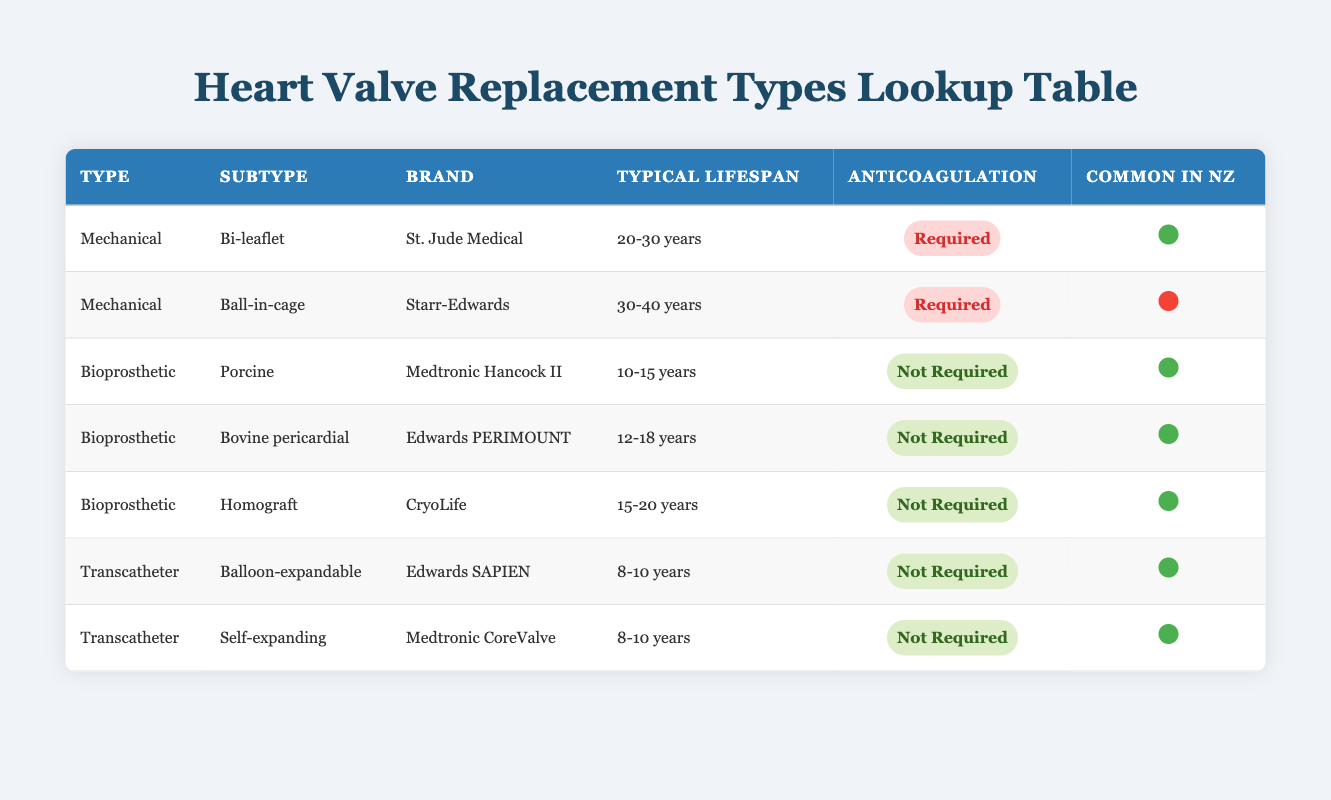What is the typical lifespan of a Bi-leaflet mechanical valve? The typical lifespan for a Bi-leaflet mechanical valve, specifically the St. Jude Medical brand, is stated in the table as 20-30 years.
Answer: 20-30 years Which replacement type requires anticoagulation? The table indicates that both subtypes of mechanical valves—Bi-leaflet and Ball-in-cage—require anticoagulation. In contrast, all bioprosthetic and transcatheter valves do not require anticoagulation.
Answer: Mechanical (Bi-leaflet, Ball-in-cage) Is the Edwards SAPIEN valve common in New Zealand? The table indicates that the Edwards SAPIEN valve, categorized under Transcatheter, is listed as common in New Zealand with a yes indicator.
Answer: Yes What is the average typical lifespan of bioprosthetic valves? The lifespan data for bioprosthetic valves are 10-15 years for the Porcine, 12-18 years for Bovine pericardial, and 15-20 years for Homograft. To find the average, we calculate: (12.5 + 15 + 17.5) / 3 = 15 years.
Answer: 15 years Which type of valve has the longest lifespan, and what is that lifespan? By inspecting the table, the Ball-in-cage mechanical valve has the longest typical lifespan of 30-40 years. This is confirmed by reviewing each replacement type's lifespan in the table.
Answer: 30-40 years What types of valves are available that do not require anticoagulation? The table shows that the following valves do not require anticoagulation: Porcine, Bovine pericardial, Homograft, Balloon-expandable, and Self-expanding. Hence, these subtypes are all of the bioprosthetic and transcatheter valve categories.
Answer: Porcine, Bovine pericardial, Homograft, Balloon-expandable, Self-expanding How many types of heart valves in this table are common in New Zealand? By reviewing the 'Common in NZ' column in the table, we identify that all subtypes of the bioprosthetic valves and the transcatheter valves (totaling 5) are marked as common, while only one subtype of mechanical valve is common, bringing a total to 6.
Answer: 6 Are there any bioprosthetic valves that have a lifespan shorter than 15 years? From the lifespan data in the table, the Porcine valve has a lifespan of 10-15 years, meaning it can indeed fall below 15 years. Therefore, there is at least one bioprosthetic valve type which has a lifespan shorter than 15 years.
Answer: Yes What types of valves have a typical lifespan of 8-10 years? The table specifically lists both the Balloon-expandable and Self-expanding transcatheter valves as having a typical lifespan of 8-10 years. Both of these valves fall under the Transcatheter replacement type.
Answer: Balloon-expandable, Self-expanding 